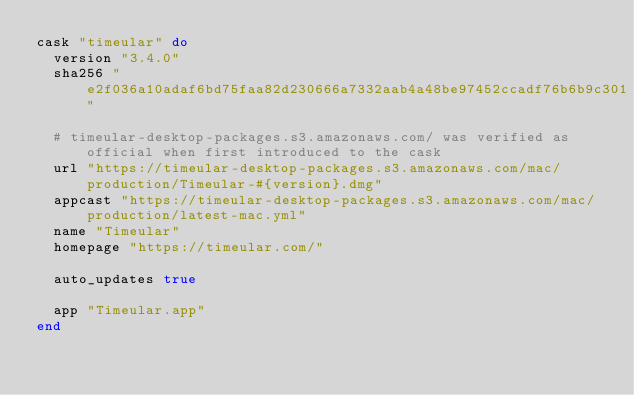<code> <loc_0><loc_0><loc_500><loc_500><_Ruby_>cask "timeular" do
  version "3.4.0"
  sha256 "e2f036a10adaf6bd75faa82d230666a7332aab4a48be97452ccadf76b6b9c301"

  # timeular-desktop-packages.s3.amazonaws.com/ was verified as official when first introduced to the cask
  url "https://timeular-desktop-packages.s3.amazonaws.com/mac/production/Timeular-#{version}.dmg"
  appcast "https://timeular-desktop-packages.s3.amazonaws.com/mac/production/latest-mac.yml"
  name "Timeular"
  homepage "https://timeular.com/"

  auto_updates true

  app "Timeular.app"
end
</code> 